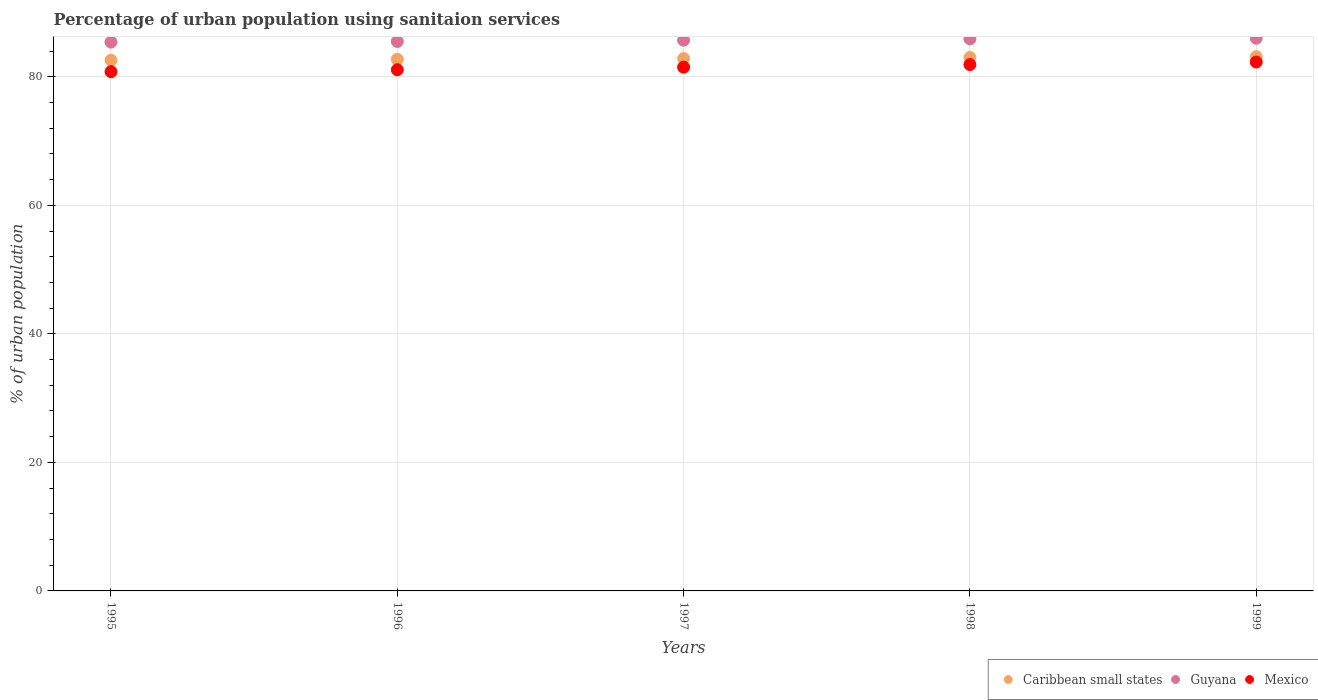Is the number of dotlines equal to the number of legend labels?
Provide a short and direct response. Yes. What is the percentage of urban population using sanitaion services in Guyana in 1995?
Offer a terse response. 85.4. Across all years, what is the maximum percentage of urban population using sanitaion services in Caribbean small states?
Provide a short and direct response. 83.12. Across all years, what is the minimum percentage of urban population using sanitaion services in Caribbean small states?
Keep it short and to the point. 82.57. What is the total percentage of urban population using sanitaion services in Guyana in the graph?
Ensure brevity in your answer.  428.5. What is the difference between the percentage of urban population using sanitaion services in Mexico in 1997 and that in 1998?
Give a very brief answer. -0.4. What is the difference between the percentage of urban population using sanitaion services in Guyana in 1997 and the percentage of urban population using sanitaion services in Mexico in 1996?
Offer a terse response. 4.6. What is the average percentage of urban population using sanitaion services in Guyana per year?
Your answer should be very brief. 85.7. In the year 1998, what is the difference between the percentage of urban population using sanitaion services in Caribbean small states and percentage of urban population using sanitaion services in Mexico?
Your answer should be compact. 1.1. In how many years, is the percentage of urban population using sanitaion services in Mexico greater than 52 %?
Provide a succinct answer. 5. What is the ratio of the percentage of urban population using sanitaion services in Mexico in 1995 to that in 1998?
Provide a short and direct response. 0.99. Is the percentage of urban population using sanitaion services in Caribbean small states in 1998 less than that in 1999?
Provide a short and direct response. Yes. Is the difference between the percentage of urban population using sanitaion services in Caribbean small states in 1995 and 1996 greater than the difference between the percentage of urban population using sanitaion services in Mexico in 1995 and 1996?
Your response must be concise. Yes. What is the difference between the highest and the second highest percentage of urban population using sanitaion services in Guyana?
Keep it short and to the point. 0.1. In how many years, is the percentage of urban population using sanitaion services in Caribbean small states greater than the average percentage of urban population using sanitaion services in Caribbean small states taken over all years?
Provide a succinct answer. 2. Is the sum of the percentage of urban population using sanitaion services in Caribbean small states in 1997 and 1999 greater than the maximum percentage of urban population using sanitaion services in Mexico across all years?
Offer a terse response. Yes. Is it the case that in every year, the sum of the percentage of urban population using sanitaion services in Caribbean small states and percentage of urban population using sanitaion services in Mexico  is greater than the percentage of urban population using sanitaion services in Guyana?
Make the answer very short. Yes. How many dotlines are there?
Keep it short and to the point. 3. What is the difference between two consecutive major ticks on the Y-axis?
Your response must be concise. 20. Are the values on the major ticks of Y-axis written in scientific E-notation?
Your answer should be very brief. No. Does the graph contain any zero values?
Give a very brief answer. No. Where does the legend appear in the graph?
Keep it short and to the point. Bottom right. How many legend labels are there?
Your answer should be compact. 3. What is the title of the graph?
Offer a very short reply. Percentage of urban population using sanitaion services. Does "Albania" appear as one of the legend labels in the graph?
Make the answer very short. No. What is the label or title of the Y-axis?
Offer a terse response. % of urban population. What is the % of urban population in Caribbean small states in 1995?
Offer a terse response. 82.57. What is the % of urban population in Guyana in 1995?
Make the answer very short. 85.4. What is the % of urban population of Mexico in 1995?
Give a very brief answer. 80.8. What is the % of urban population of Caribbean small states in 1996?
Provide a short and direct response. 82.73. What is the % of urban population in Guyana in 1996?
Ensure brevity in your answer.  85.5. What is the % of urban population of Mexico in 1996?
Offer a very short reply. 81.1. What is the % of urban population of Caribbean small states in 1997?
Provide a short and direct response. 82.84. What is the % of urban population of Guyana in 1997?
Keep it short and to the point. 85.7. What is the % of urban population of Mexico in 1997?
Keep it short and to the point. 81.5. What is the % of urban population of Caribbean small states in 1998?
Give a very brief answer. 83. What is the % of urban population of Guyana in 1998?
Provide a short and direct response. 85.9. What is the % of urban population of Mexico in 1998?
Give a very brief answer. 81.9. What is the % of urban population of Caribbean small states in 1999?
Your answer should be very brief. 83.12. What is the % of urban population of Mexico in 1999?
Provide a succinct answer. 82.3. Across all years, what is the maximum % of urban population of Caribbean small states?
Offer a very short reply. 83.12. Across all years, what is the maximum % of urban population of Guyana?
Keep it short and to the point. 86. Across all years, what is the maximum % of urban population of Mexico?
Your response must be concise. 82.3. Across all years, what is the minimum % of urban population of Caribbean small states?
Provide a short and direct response. 82.57. Across all years, what is the minimum % of urban population in Guyana?
Your response must be concise. 85.4. Across all years, what is the minimum % of urban population in Mexico?
Offer a terse response. 80.8. What is the total % of urban population of Caribbean small states in the graph?
Provide a succinct answer. 414.27. What is the total % of urban population of Guyana in the graph?
Offer a terse response. 428.5. What is the total % of urban population in Mexico in the graph?
Your answer should be very brief. 407.6. What is the difference between the % of urban population of Caribbean small states in 1995 and that in 1996?
Provide a succinct answer. -0.15. What is the difference between the % of urban population of Guyana in 1995 and that in 1996?
Give a very brief answer. -0.1. What is the difference between the % of urban population in Mexico in 1995 and that in 1996?
Your answer should be compact. -0.3. What is the difference between the % of urban population in Caribbean small states in 1995 and that in 1997?
Ensure brevity in your answer.  -0.27. What is the difference between the % of urban population of Caribbean small states in 1995 and that in 1998?
Provide a succinct answer. -0.43. What is the difference between the % of urban population of Guyana in 1995 and that in 1998?
Your answer should be very brief. -0.5. What is the difference between the % of urban population in Caribbean small states in 1995 and that in 1999?
Your response must be concise. -0.55. What is the difference between the % of urban population in Caribbean small states in 1996 and that in 1997?
Your response must be concise. -0.12. What is the difference between the % of urban population in Mexico in 1996 and that in 1997?
Offer a terse response. -0.4. What is the difference between the % of urban population in Caribbean small states in 1996 and that in 1998?
Provide a short and direct response. -0.28. What is the difference between the % of urban population of Mexico in 1996 and that in 1998?
Your answer should be very brief. -0.8. What is the difference between the % of urban population of Caribbean small states in 1996 and that in 1999?
Provide a succinct answer. -0.4. What is the difference between the % of urban population of Guyana in 1996 and that in 1999?
Provide a succinct answer. -0.5. What is the difference between the % of urban population of Caribbean small states in 1997 and that in 1998?
Keep it short and to the point. -0.16. What is the difference between the % of urban population in Guyana in 1997 and that in 1998?
Your answer should be very brief. -0.2. What is the difference between the % of urban population of Caribbean small states in 1997 and that in 1999?
Provide a short and direct response. -0.28. What is the difference between the % of urban population of Guyana in 1997 and that in 1999?
Provide a succinct answer. -0.3. What is the difference between the % of urban population in Mexico in 1997 and that in 1999?
Give a very brief answer. -0.8. What is the difference between the % of urban population in Caribbean small states in 1998 and that in 1999?
Make the answer very short. -0.12. What is the difference between the % of urban population of Caribbean small states in 1995 and the % of urban population of Guyana in 1996?
Provide a succinct answer. -2.92. What is the difference between the % of urban population of Caribbean small states in 1995 and the % of urban population of Mexico in 1996?
Ensure brevity in your answer.  1.48. What is the difference between the % of urban population of Guyana in 1995 and the % of urban population of Mexico in 1996?
Offer a very short reply. 4.3. What is the difference between the % of urban population of Caribbean small states in 1995 and the % of urban population of Guyana in 1997?
Your response must be concise. -3.12. What is the difference between the % of urban population in Caribbean small states in 1995 and the % of urban population in Mexico in 1997?
Provide a succinct answer. 1.07. What is the difference between the % of urban population of Caribbean small states in 1995 and the % of urban population of Guyana in 1998?
Make the answer very short. -3.33. What is the difference between the % of urban population in Caribbean small states in 1995 and the % of urban population in Mexico in 1998?
Offer a terse response. 0.68. What is the difference between the % of urban population of Caribbean small states in 1995 and the % of urban population of Guyana in 1999?
Provide a short and direct response. -3.42. What is the difference between the % of urban population of Caribbean small states in 1995 and the % of urban population of Mexico in 1999?
Your response must be concise. 0.28. What is the difference between the % of urban population of Caribbean small states in 1996 and the % of urban population of Guyana in 1997?
Your answer should be compact. -2.97. What is the difference between the % of urban population of Caribbean small states in 1996 and the % of urban population of Mexico in 1997?
Your answer should be very brief. 1.23. What is the difference between the % of urban population of Guyana in 1996 and the % of urban population of Mexico in 1997?
Ensure brevity in your answer.  4. What is the difference between the % of urban population of Caribbean small states in 1996 and the % of urban population of Guyana in 1998?
Give a very brief answer. -3.17. What is the difference between the % of urban population in Caribbean small states in 1996 and the % of urban population in Mexico in 1998?
Ensure brevity in your answer.  0.83. What is the difference between the % of urban population in Guyana in 1996 and the % of urban population in Mexico in 1998?
Offer a terse response. 3.6. What is the difference between the % of urban population in Caribbean small states in 1996 and the % of urban population in Guyana in 1999?
Your answer should be very brief. -3.27. What is the difference between the % of urban population of Caribbean small states in 1996 and the % of urban population of Mexico in 1999?
Your answer should be very brief. 0.43. What is the difference between the % of urban population in Caribbean small states in 1997 and the % of urban population in Guyana in 1998?
Provide a succinct answer. -3.06. What is the difference between the % of urban population in Caribbean small states in 1997 and the % of urban population in Mexico in 1998?
Keep it short and to the point. 0.94. What is the difference between the % of urban population of Guyana in 1997 and the % of urban population of Mexico in 1998?
Your response must be concise. 3.8. What is the difference between the % of urban population of Caribbean small states in 1997 and the % of urban population of Guyana in 1999?
Provide a short and direct response. -3.16. What is the difference between the % of urban population of Caribbean small states in 1997 and the % of urban population of Mexico in 1999?
Offer a very short reply. 0.54. What is the difference between the % of urban population in Guyana in 1997 and the % of urban population in Mexico in 1999?
Your response must be concise. 3.4. What is the difference between the % of urban population of Caribbean small states in 1998 and the % of urban population of Guyana in 1999?
Your answer should be compact. -3. What is the difference between the % of urban population in Caribbean small states in 1998 and the % of urban population in Mexico in 1999?
Ensure brevity in your answer.  0.7. What is the difference between the % of urban population of Guyana in 1998 and the % of urban population of Mexico in 1999?
Keep it short and to the point. 3.6. What is the average % of urban population in Caribbean small states per year?
Make the answer very short. 82.85. What is the average % of urban population of Guyana per year?
Provide a succinct answer. 85.7. What is the average % of urban population of Mexico per year?
Your response must be concise. 81.52. In the year 1995, what is the difference between the % of urban population in Caribbean small states and % of urban population in Guyana?
Give a very brief answer. -2.83. In the year 1995, what is the difference between the % of urban population in Caribbean small states and % of urban population in Mexico?
Ensure brevity in your answer.  1.77. In the year 1995, what is the difference between the % of urban population in Guyana and % of urban population in Mexico?
Make the answer very short. 4.6. In the year 1996, what is the difference between the % of urban population in Caribbean small states and % of urban population in Guyana?
Provide a succinct answer. -2.77. In the year 1996, what is the difference between the % of urban population of Caribbean small states and % of urban population of Mexico?
Provide a succinct answer. 1.63. In the year 1996, what is the difference between the % of urban population of Guyana and % of urban population of Mexico?
Provide a succinct answer. 4.4. In the year 1997, what is the difference between the % of urban population of Caribbean small states and % of urban population of Guyana?
Keep it short and to the point. -2.86. In the year 1997, what is the difference between the % of urban population in Caribbean small states and % of urban population in Mexico?
Provide a succinct answer. 1.34. In the year 1997, what is the difference between the % of urban population in Guyana and % of urban population in Mexico?
Offer a terse response. 4.2. In the year 1998, what is the difference between the % of urban population in Caribbean small states and % of urban population in Guyana?
Your answer should be compact. -2.9. In the year 1998, what is the difference between the % of urban population of Caribbean small states and % of urban population of Mexico?
Provide a short and direct response. 1.1. In the year 1998, what is the difference between the % of urban population in Guyana and % of urban population in Mexico?
Ensure brevity in your answer.  4. In the year 1999, what is the difference between the % of urban population in Caribbean small states and % of urban population in Guyana?
Provide a short and direct response. -2.88. In the year 1999, what is the difference between the % of urban population in Caribbean small states and % of urban population in Mexico?
Offer a terse response. 0.82. What is the ratio of the % of urban population of Caribbean small states in 1995 to that in 1996?
Give a very brief answer. 1. What is the ratio of the % of urban population of Caribbean small states in 1995 to that in 1997?
Your answer should be compact. 1. What is the ratio of the % of urban population in Caribbean small states in 1995 to that in 1998?
Offer a terse response. 0.99. What is the ratio of the % of urban population in Mexico in 1995 to that in 1998?
Ensure brevity in your answer.  0.99. What is the ratio of the % of urban population in Mexico in 1995 to that in 1999?
Your answer should be very brief. 0.98. What is the ratio of the % of urban population in Guyana in 1996 to that in 1997?
Offer a very short reply. 1. What is the ratio of the % of urban population in Mexico in 1996 to that in 1997?
Make the answer very short. 1. What is the ratio of the % of urban population in Guyana in 1996 to that in 1998?
Provide a succinct answer. 1. What is the ratio of the % of urban population in Mexico in 1996 to that in 1998?
Offer a terse response. 0.99. What is the ratio of the % of urban population of Guyana in 1996 to that in 1999?
Your answer should be compact. 0.99. What is the ratio of the % of urban population in Mexico in 1996 to that in 1999?
Ensure brevity in your answer.  0.99. What is the ratio of the % of urban population of Caribbean small states in 1997 to that in 1998?
Give a very brief answer. 1. What is the ratio of the % of urban population of Mexico in 1997 to that in 1998?
Make the answer very short. 1. What is the ratio of the % of urban population of Guyana in 1997 to that in 1999?
Offer a terse response. 1. What is the ratio of the % of urban population of Mexico in 1997 to that in 1999?
Offer a very short reply. 0.99. What is the ratio of the % of urban population of Guyana in 1998 to that in 1999?
Offer a terse response. 1. What is the ratio of the % of urban population in Mexico in 1998 to that in 1999?
Offer a terse response. 1. What is the difference between the highest and the second highest % of urban population of Caribbean small states?
Your response must be concise. 0.12. What is the difference between the highest and the lowest % of urban population of Caribbean small states?
Provide a succinct answer. 0.55. What is the difference between the highest and the lowest % of urban population of Guyana?
Give a very brief answer. 0.6. What is the difference between the highest and the lowest % of urban population in Mexico?
Your response must be concise. 1.5. 